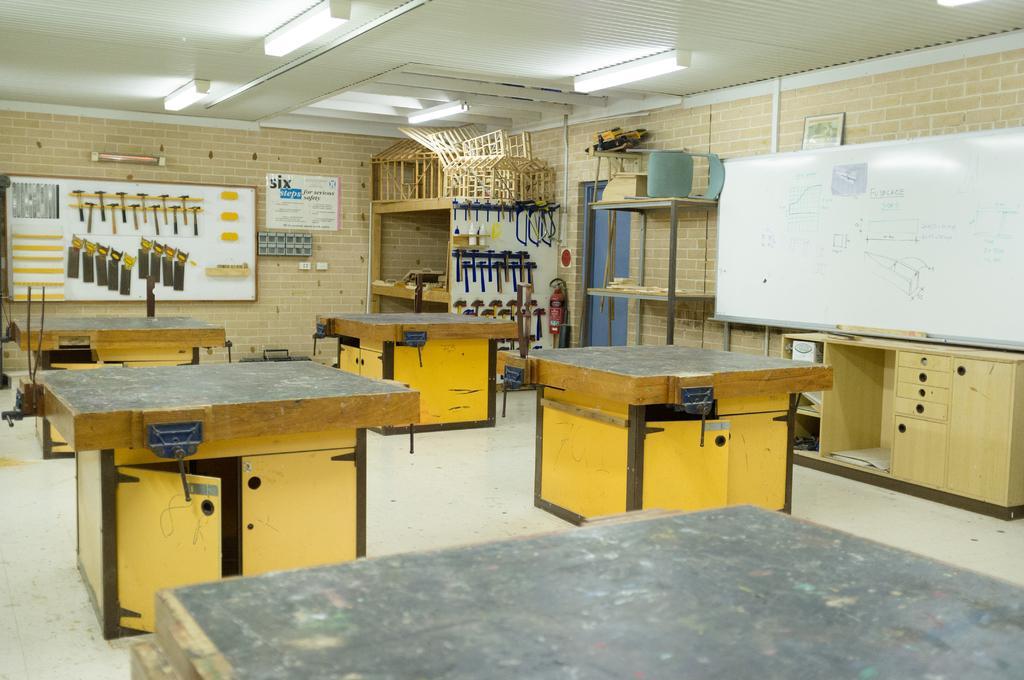How would you summarize this image in a sentence or two? In this image it looks like a machine workshop where there are four desks in the middle. On the right side there is a white board on which there is some text. In the background there is a board on which there are hammers and ace. At the top there is ceiling with the lights. On the right side in the background there are cutting tools. 